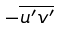<formula> <loc_0><loc_0><loc_500><loc_500>- \overline { u ^ { \prime } v ^ { \prime } }</formula> 